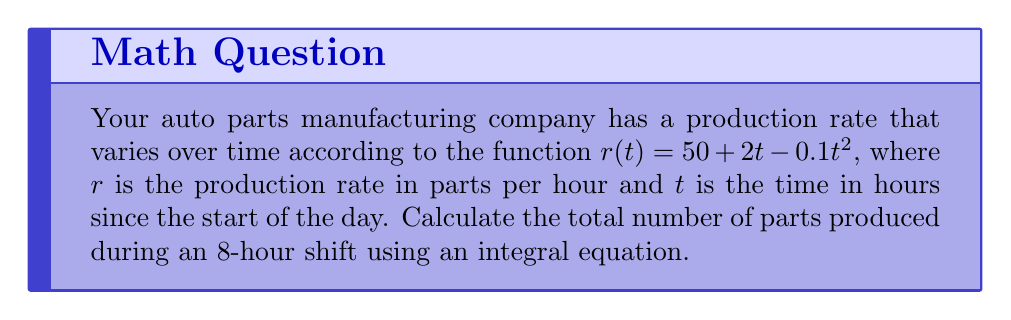Give your solution to this math problem. To calculate the total production output over time, we need to integrate the production rate function over the given time interval. Here's how we solve this problem:

1. The production rate function is given as:
   $r(t) = 50 + 2t - 0.1t^2$

2. To find the total production, we need to integrate this function from $t=0$ to $t=8$:
   $$\text{Total Production} = \int_{0}^{8} (50 + 2t - 0.1t^2) dt$$

3. Let's integrate each term separately:
   $$\int_{0}^{8} 50 dt + \int_{0}^{8} 2t dt - \int_{0}^{8} 0.1t^2 dt$$

4. Integrate:
   $$[50t]_{0}^{8} + [t^2]_{0}^{8} - [0.1\frac{t^3}{3}]_{0}^{8}$$

5. Evaluate the definite integral:
   $$(50 \cdot 8) + (8^2 - 0^2) - (0.1 \cdot \frac{8^3}{3} - 0)$$

6. Simplify:
   $$400 + 64 - (0.1 \cdot \frac{512}{3})$$

7. Calculate:
   $$464 - 17.0666...$$

8. Final result:
   $$446.93 \text{ (rounded to two decimal places)}$$

Therefore, the total number of parts produced during the 8-hour shift is approximately 446.93 parts.
Answer: 446.93 parts 